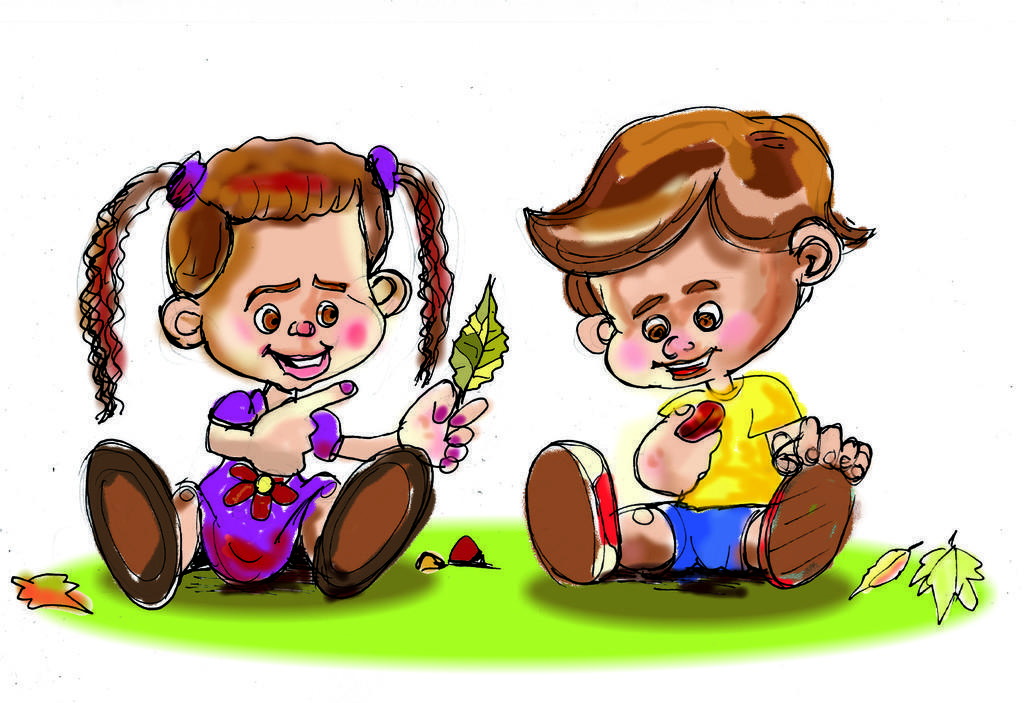How would you summarize this image in a sentence or two? This is a painting,in this painting we can see a girl,boy sitting on a platform,and a girl is holding a leaf. 